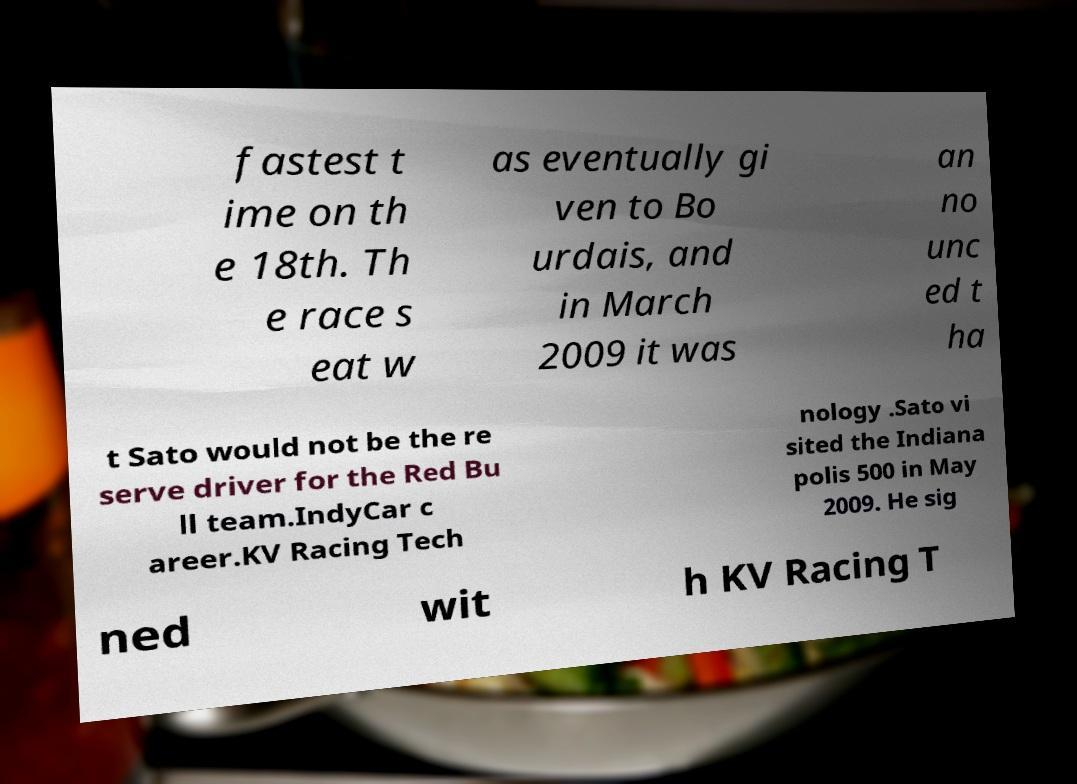For documentation purposes, I need the text within this image transcribed. Could you provide that? fastest t ime on th e 18th. Th e race s eat w as eventually gi ven to Bo urdais, and in March 2009 it was an no unc ed t ha t Sato would not be the re serve driver for the Red Bu ll team.IndyCar c areer.KV Racing Tech nology .Sato vi sited the Indiana polis 500 in May 2009. He sig ned wit h KV Racing T 